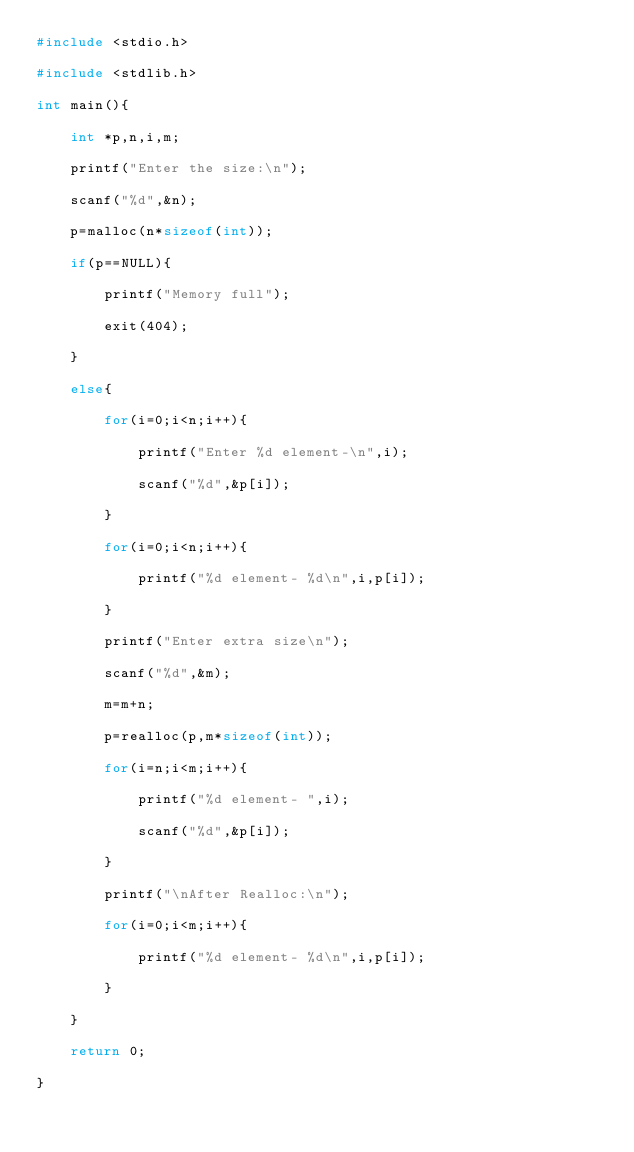<code> <loc_0><loc_0><loc_500><loc_500><_C_>#include <stdio.h>

#include <stdlib.h>

int main(){

    int *p,n,i,m;

    printf("Enter the size:\n");

    scanf("%d",&n);

    p=malloc(n*sizeof(int));

    if(p==NULL){

        printf("Memory full");

        exit(404);

    }

    else{

        for(i=0;i<n;i++){

            printf("Enter %d element-\n",i);

            scanf("%d",&p[i]);

        }

        for(i=0;i<n;i++){

            printf("%d element- %d\n",i,p[i]);

        }

        printf("Enter extra size\n");

        scanf("%d",&m);

        m=m+n;

        p=realloc(p,m*sizeof(int));

        for(i=n;i<m;i++){

            printf("%d element- ",i);

            scanf("%d",&p[i]);

        }

        printf("\nAfter Realloc:\n");

        for(i=0;i<m;i++){

            printf("%d element- %d\n",i,p[i]);

        }

    }

    return 0;

}
</code> 